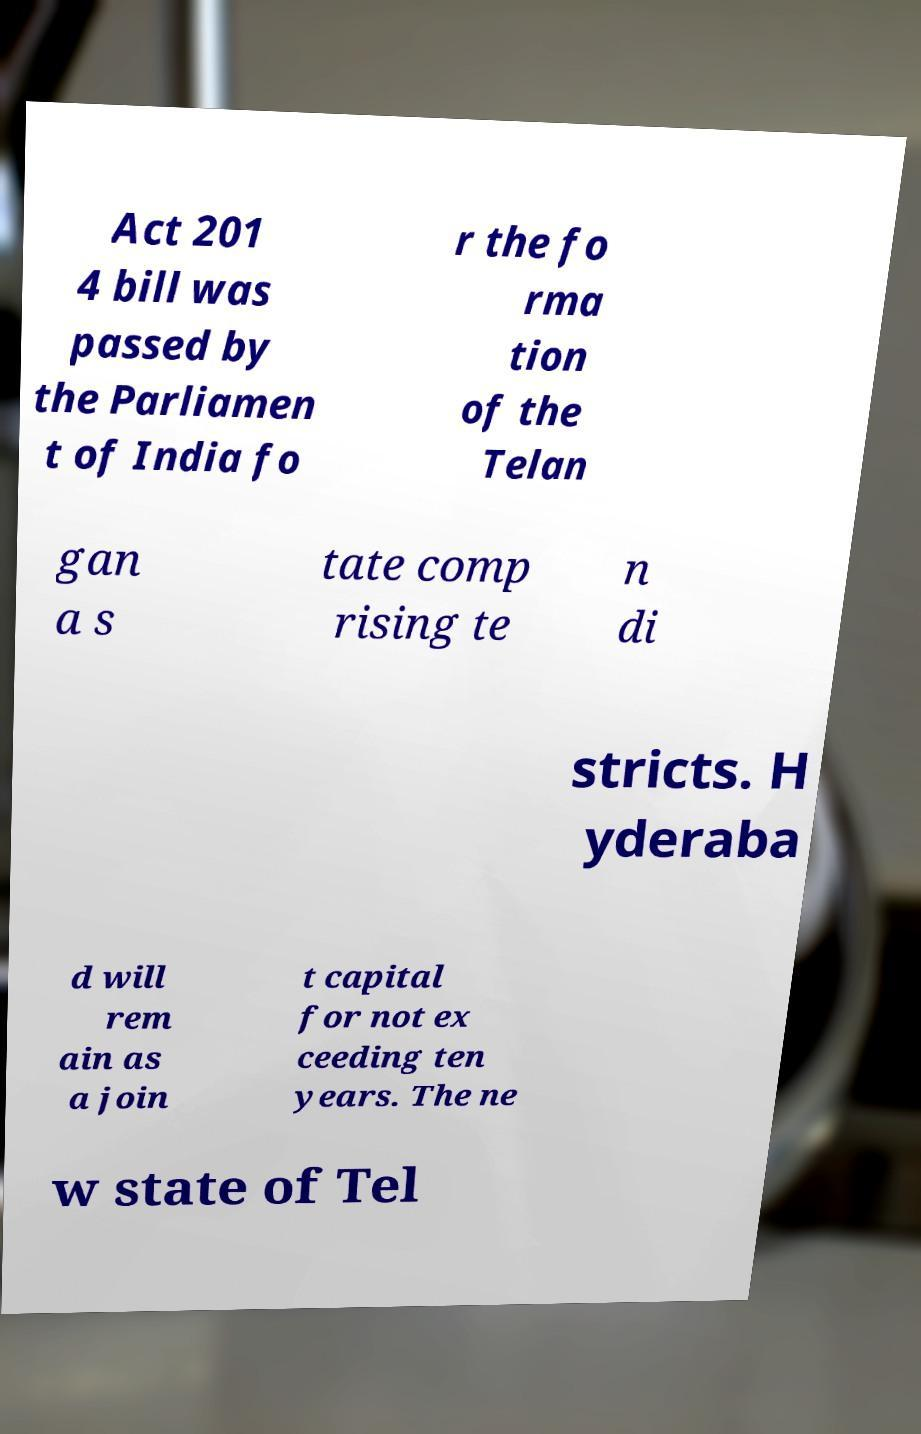I need the written content from this picture converted into text. Can you do that? Act 201 4 bill was passed by the Parliamen t of India fo r the fo rma tion of the Telan gan a s tate comp rising te n di stricts. H yderaba d will rem ain as a join t capital for not ex ceeding ten years. The ne w state of Tel 